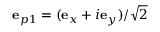Convert formula to latex. <formula><loc_0><loc_0><loc_500><loc_500>{ e } _ { p 1 } = ( { e } _ { x } + i { e } _ { y } ) / \sqrt { 2 }</formula> 